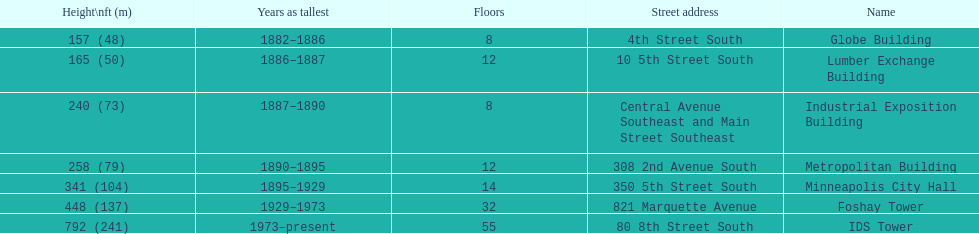Name the tallest building. IDS Tower. 